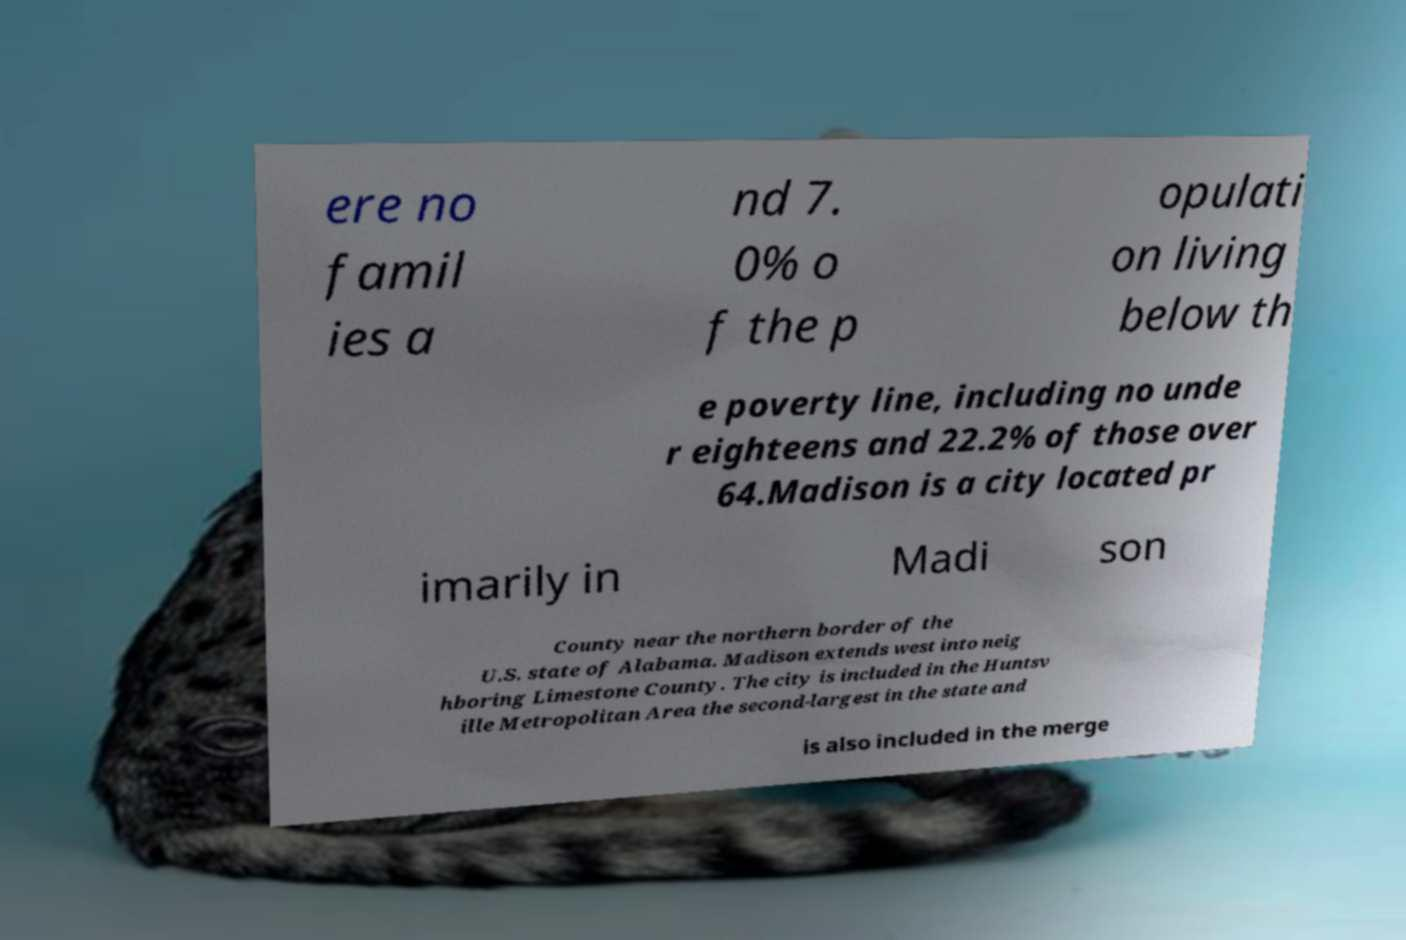Can you read and provide the text displayed in the image?This photo seems to have some interesting text. Can you extract and type it out for me? ere no famil ies a nd 7. 0% o f the p opulati on living below th e poverty line, including no unde r eighteens and 22.2% of those over 64.Madison is a city located pr imarily in Madi son County near the northern border of the U.S. state of Alabama. Madison extends west into neig hboring Limestone County. The city is included in the Huntsv ille Metropolitan Area the second-largest in the state and is also included in the merge 